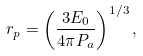<formula> <loc_0><loc_0><loc_500><loc_500>r _ { p } = \left ( \frac { 3 E _ { 0 } } { 4 \pi P _ { a } } \right ) ^ { 1 / 3 } ,</formula> 